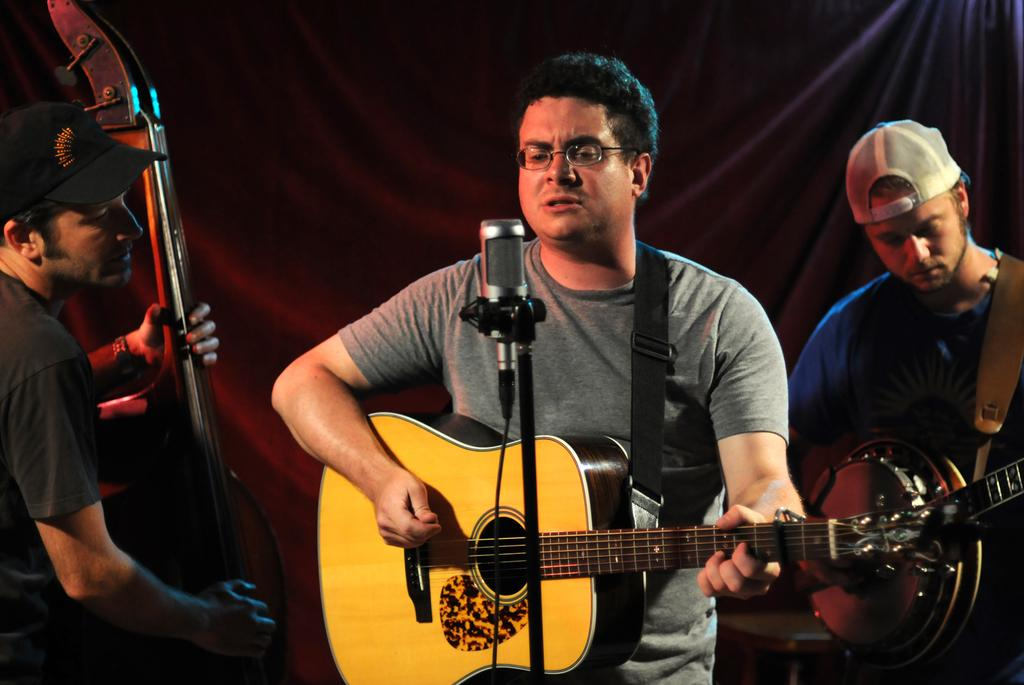How many people are in the image? There are three persons in the image. What are the persons doing in the image? The persons are playing guitars. What object is present for amplifying sound? There is a microphone (mike) in the image. Can you describe any accessories worn by the persons? One person has spectacles, and one person is wearing a cap. What type of skin can be seen on the river in the image? There is no river present in the image, and therefore no skin can be observed on it. 